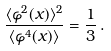<formula> <loc_0><loc_0><loc_500><loc_500>\frac { \langle \varphi ^ { 2 } ( x ) \rangle ^ { 2 } } { \langle \varphi ^ { 4 } ( x ) \rangle } = \frac { 1 } { 3 } \, .</formula> 